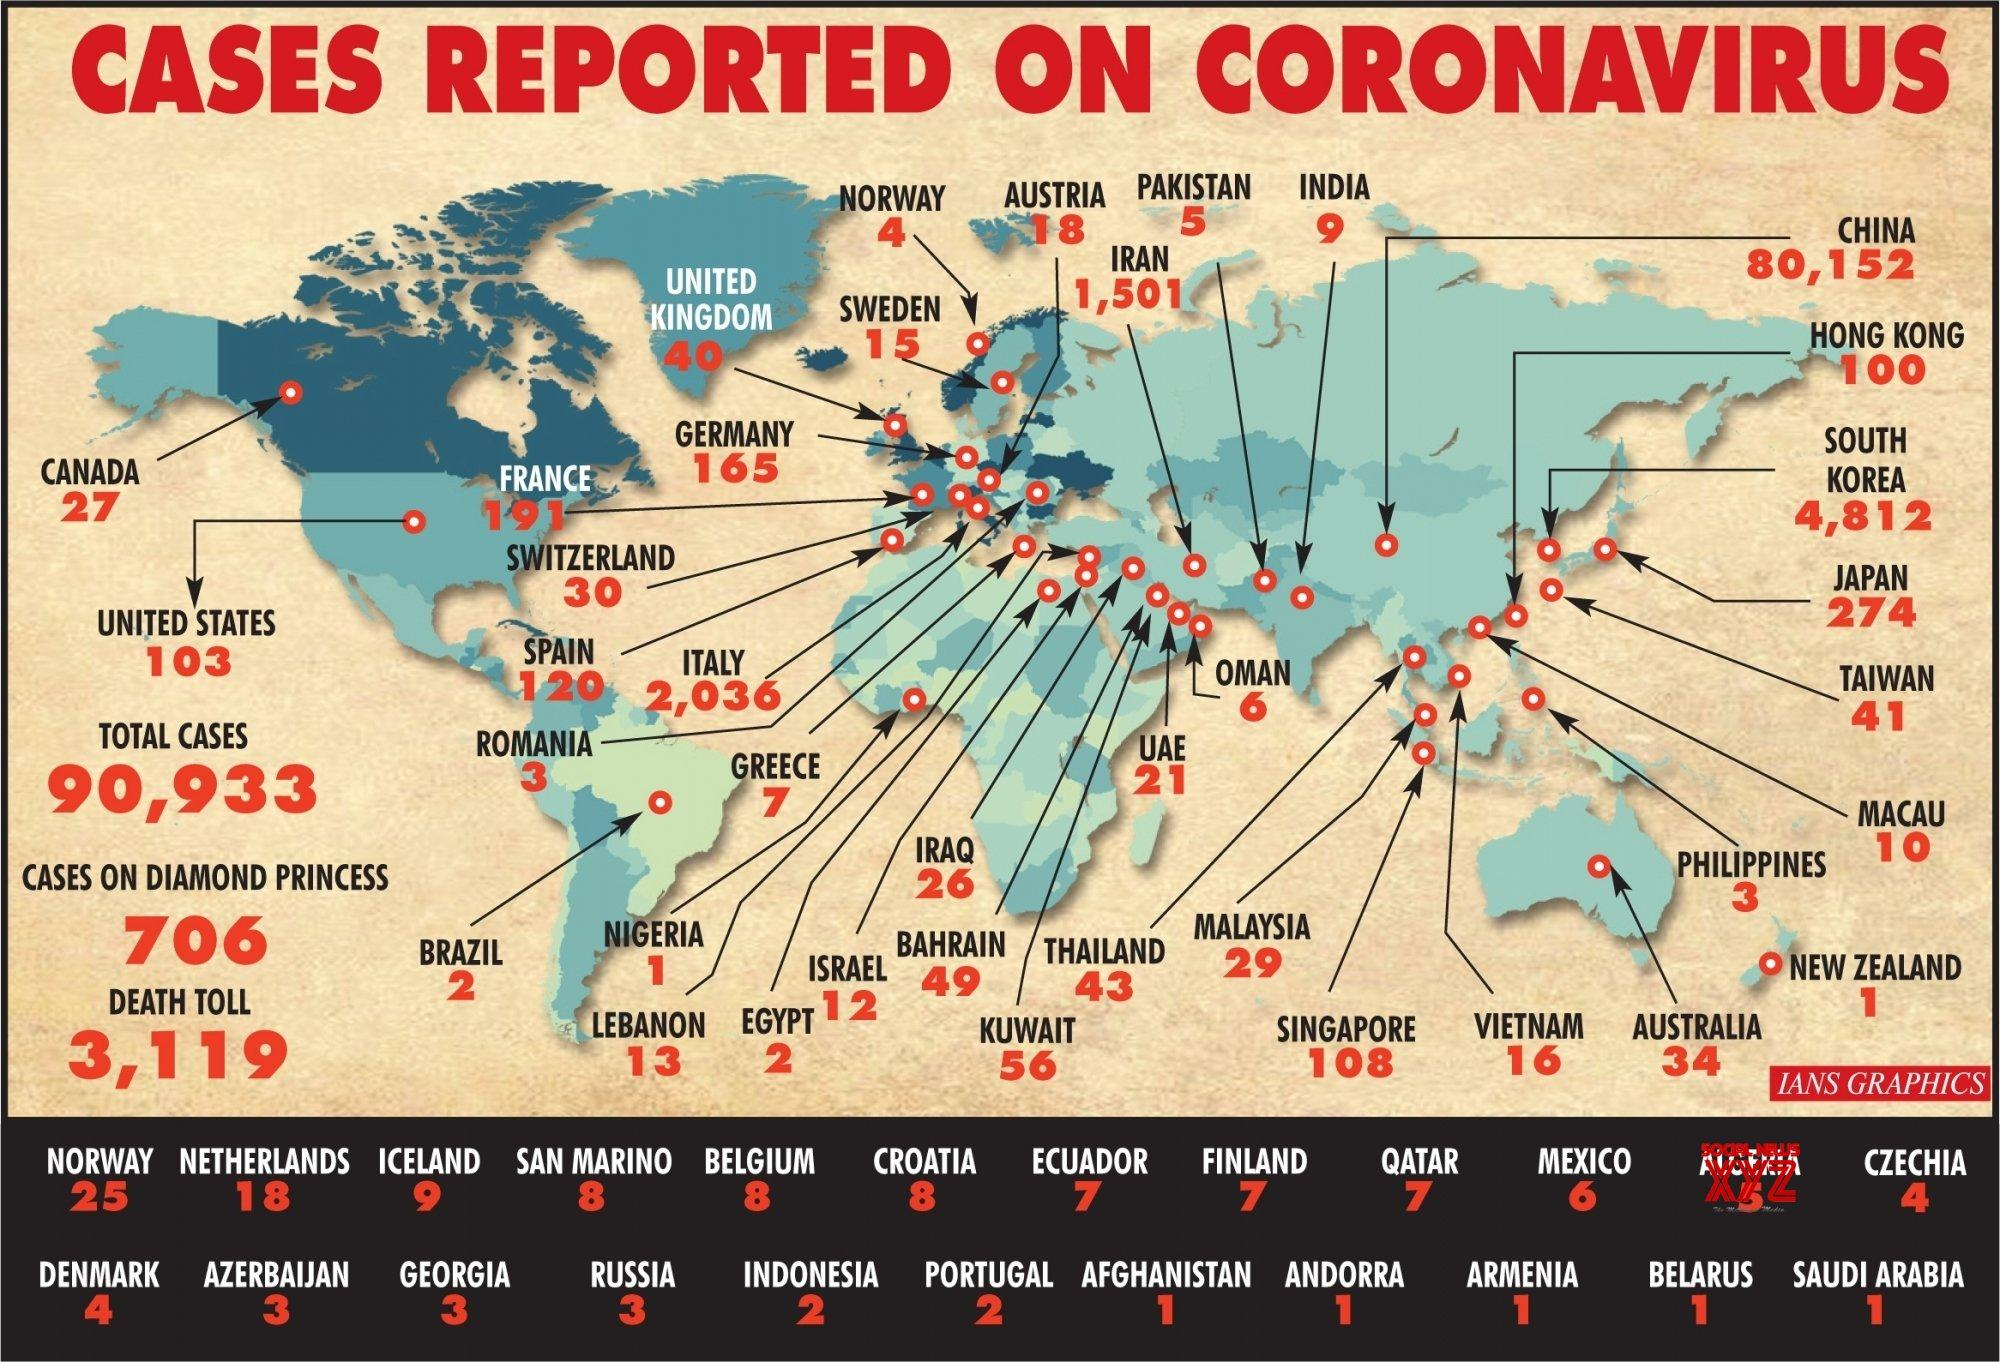Indicate a few pertinent items in this graphic. Italy has reported the third highest number of COVID-19 cases globally. As of February 2023, Qatar has reported 7 cases of COVID-19. South Korea has reported the second highest number of COVID-19 cases globally, according to reported data. As of February 22, 2023, there have been 34 reported cases of COVID-19 in Australia. As of March 13, 2023, globally reported COVID-19 deaths total 3,119. 